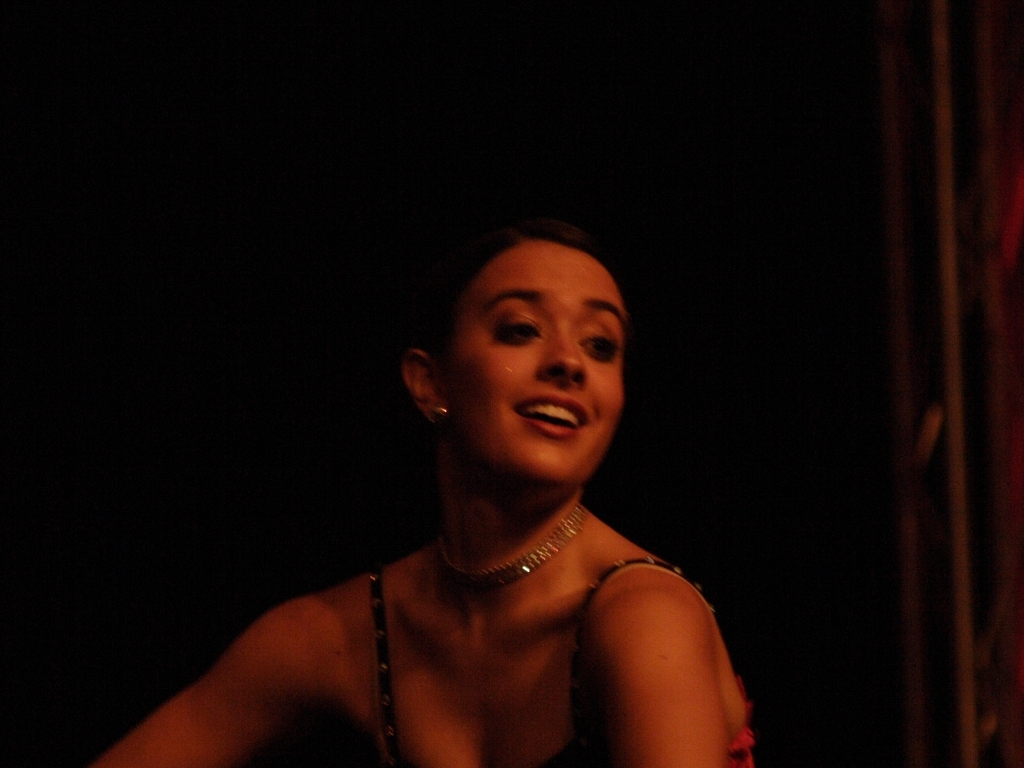What kind of emotion do you think the person in the image is expressing? The subject appears to be expressing a sense of joy or elation, possibly due to a performance, given her attire and the hint of a stage context. Can you tell anything about the setting where this photo was taken? The dim background and spotlight suggest a performance setting, likely a stage during an event such as dance or theater. 